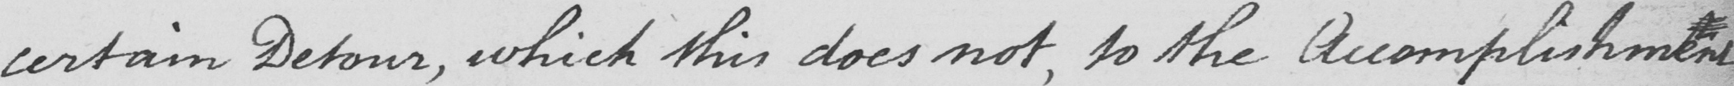What does this handwritten line say? certain Detour , which this does not , to the Accomplishment 